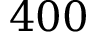Convert formula to latex. <formula><loc_0><loc_0><loc_500><loc_500>4 0 0</formula> 